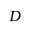Convert formula to latex. <formula><loc_0><loc_0><loc_500><loc_500>D</formula> 